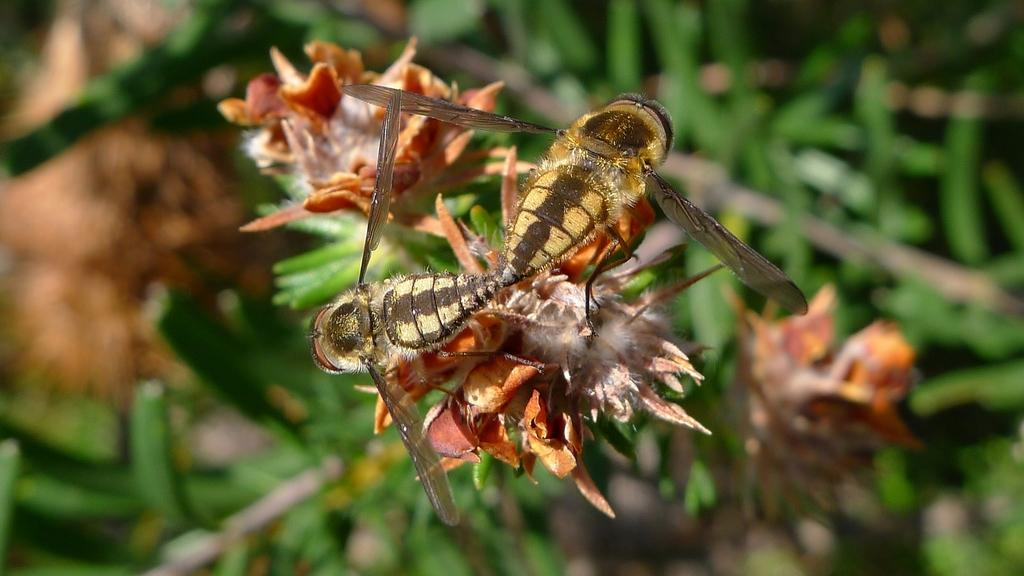What type of creatures are in the image? There are two insects in the image. Where are the insects located? The insects are on a flower. What can be observed about the background of the image? The background of the image is blurred. What type of vein can be seen running through the tin in the image? There is no tin or vein present in the image; it features two insects on a flower. 